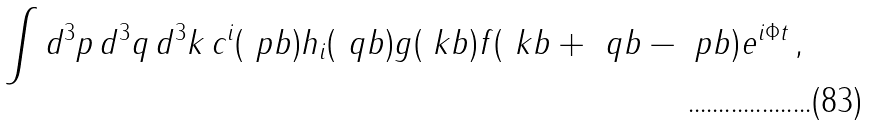Convert formula to latex. <formula><loc_0><loc_0><loc_500><loc_500>\int d ^ { 3 } p \, d ^ { 3 } q \, d ^ { 3 } k \, c ^ { i } ( \ p b ) h _ { i } ( \ q b ) g ( \ k b ) f ( \ k b + \ q b - \ p b ) e ^ { i \Phi t } \, ,</formula> 